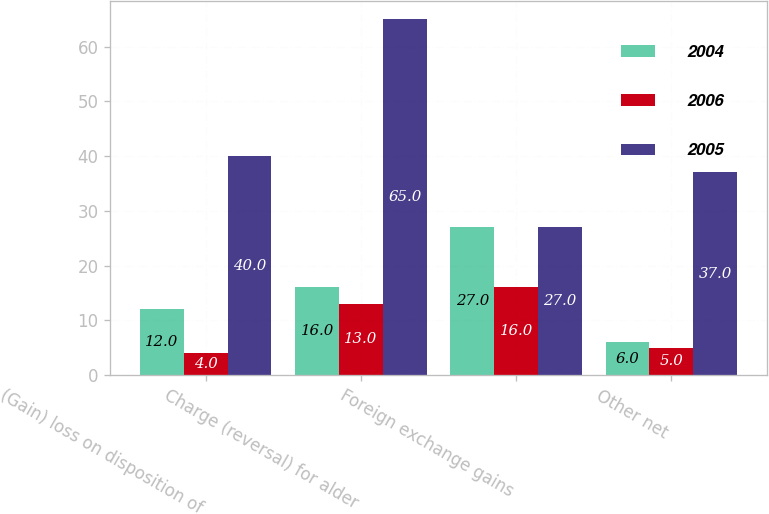Convert chart. <chart><loc_0><loc_0><loc_500><loc_500><stacked_bar_chart><ecel><fcel>(Gain) loss on disposition of<fcel>Charge (reversal) for alder<fcel>Foreign exchange gains<fcel>Other net<nl><fcel>2004<fcel>12<fcel>16<fcel>27<fcel>6<nl><fcel>2006<fcel>4<fcel>13<fcel>16<fcel>5<nl><fcel>2005<fcel>40<fcel>65<fcel>27<fcel>37<nl></chart> 